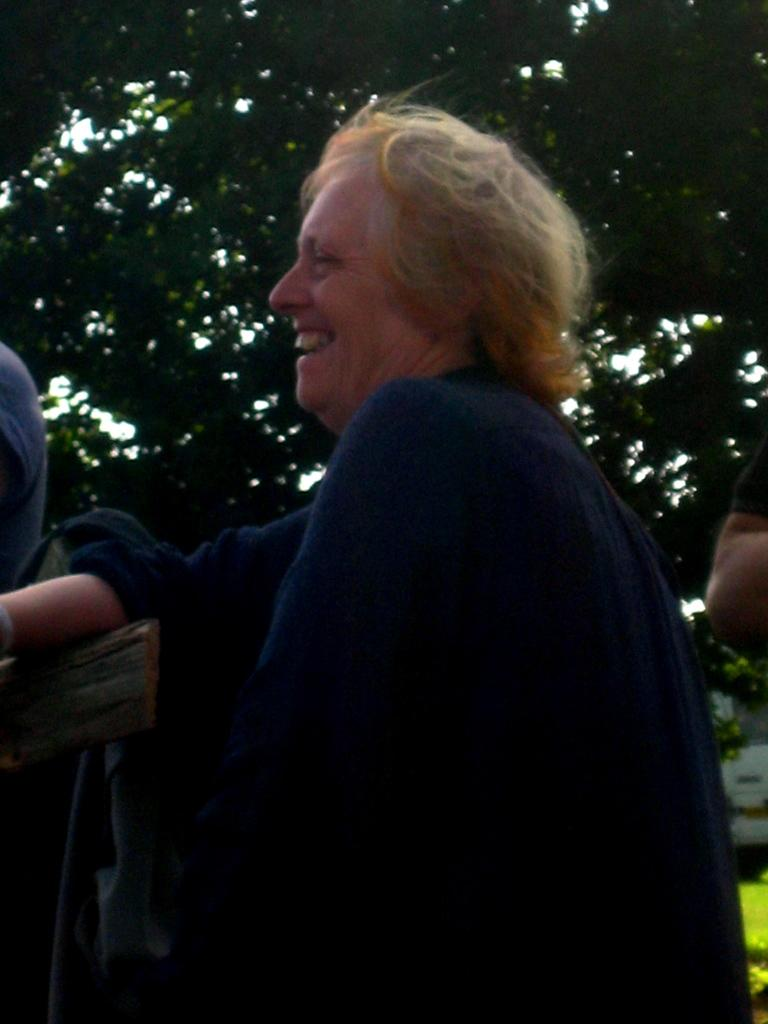What is the primary subject of the image? There is a person standing in the image. What is the person doing with her hand? The person has her hand on an object. How many other people are in the image? There are two other persons in the image. What can be seen in the background of the image? There are trees in the background of the image. What type of shoe is visible on the person's foot in the image? There is no shoe visible on the person's foot in the image. How much dust can be seen on the object the person is touching in the image? There is no mention of dust in the image, and the object the person is touching is not described in detail. 